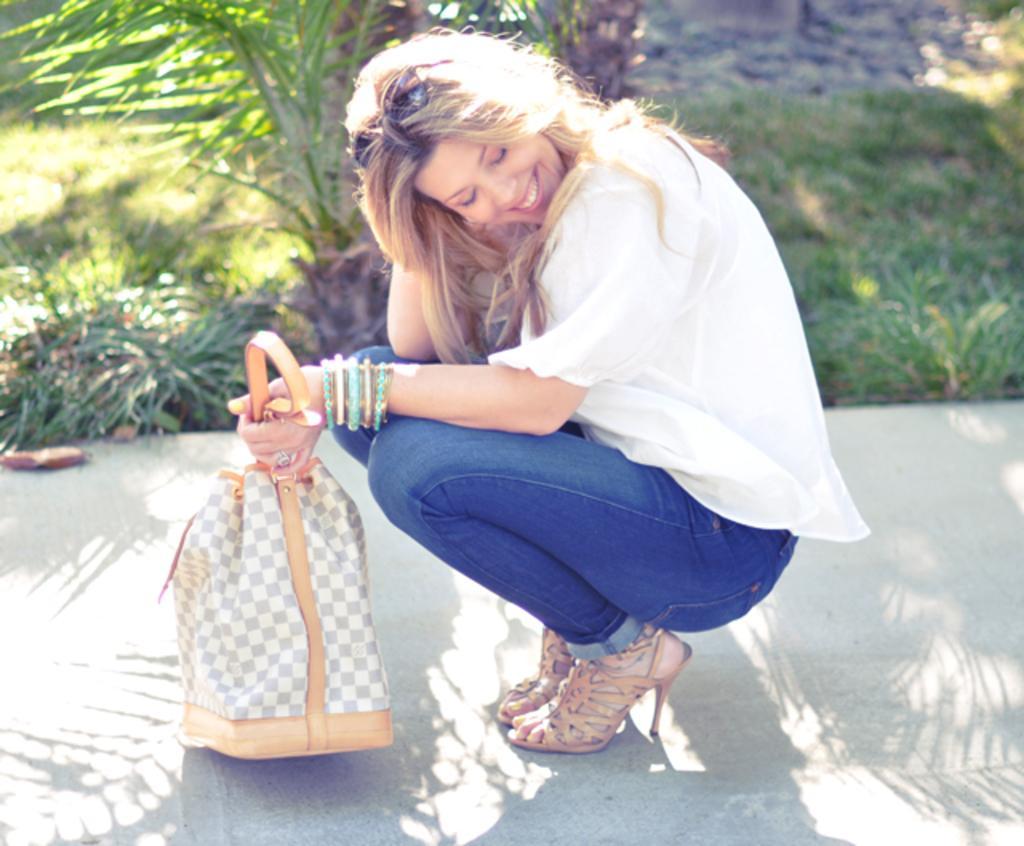Please provide a concise description of this image. In the center of the image, we can see a lady smiling and sitting on the knees and holding a bag. In the background, there are trees. At the bottom, there is a road and we can see some plants. 